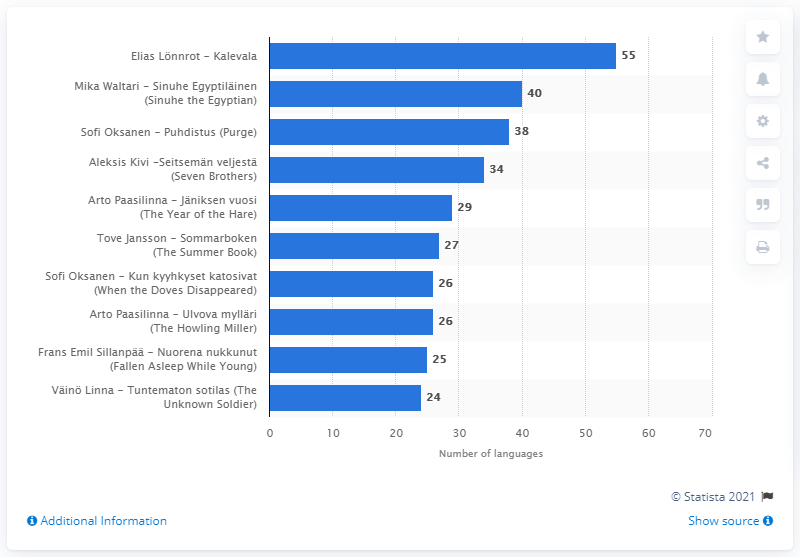Specify some key components in this picture. The Kalevala has been translated into 55 different languages. 